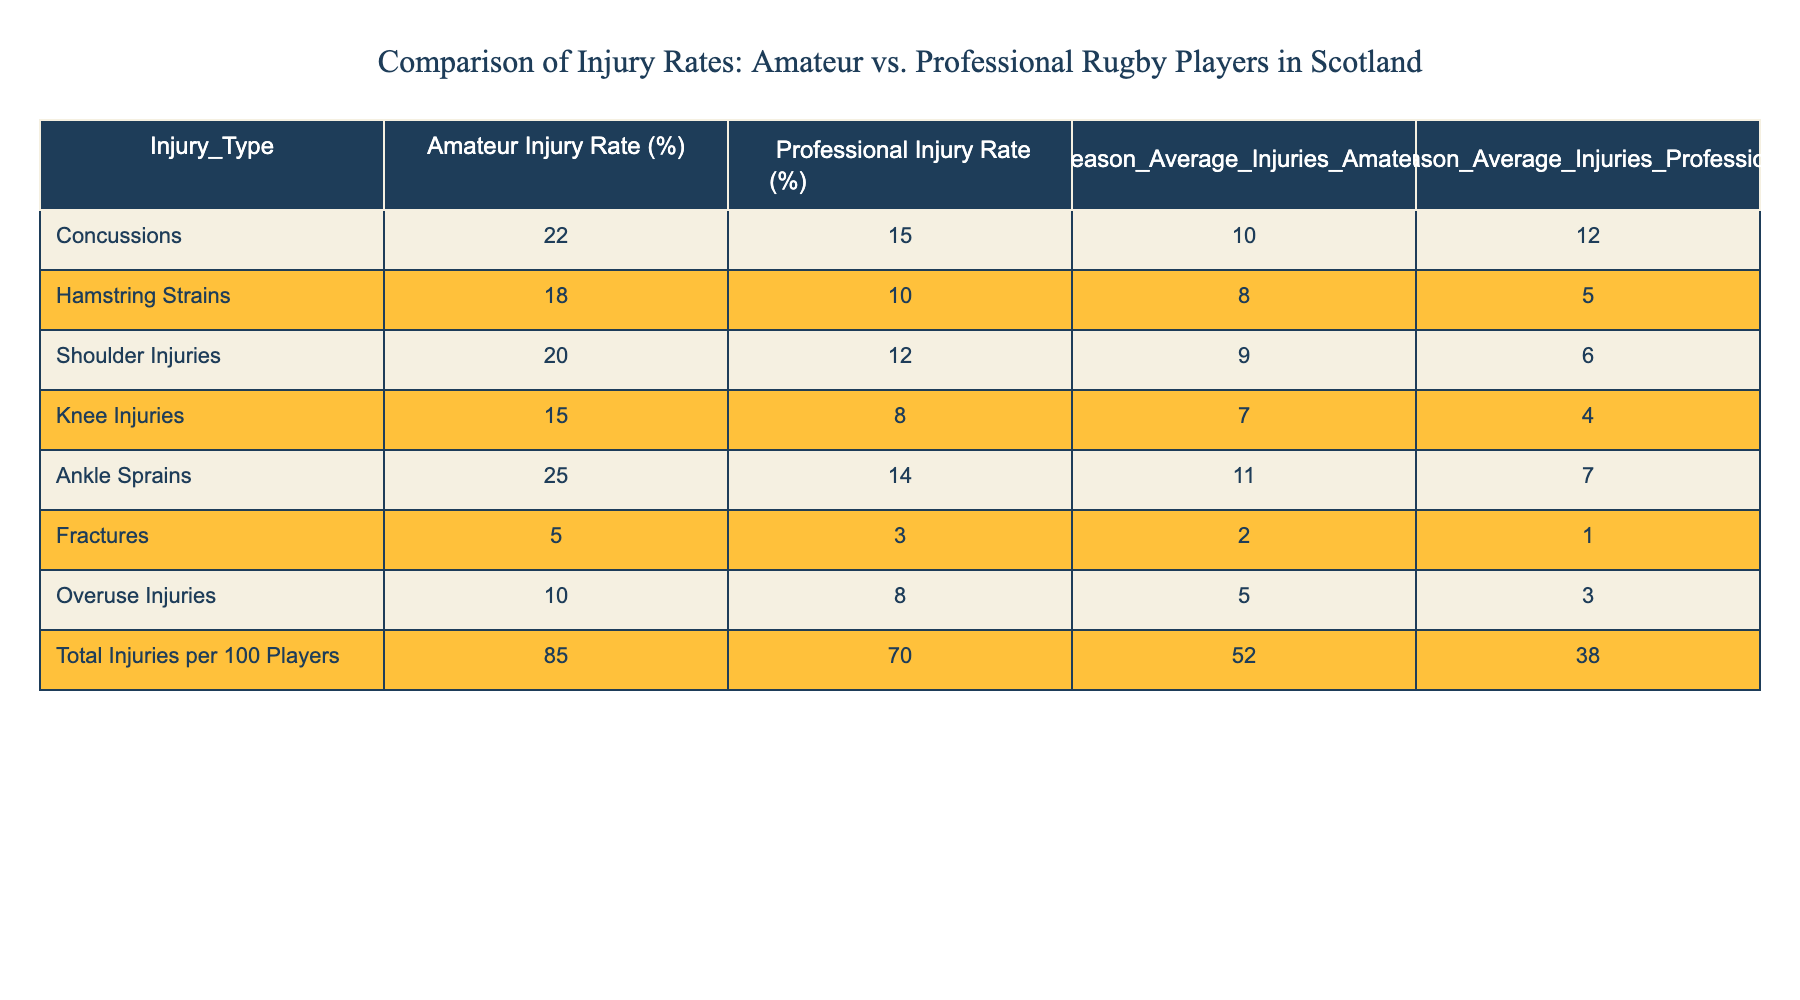What is the injury rate for concussions among amateur rugby players? The data shows that the injury rate for concussions among amateur rugby players is listed as 22%.
Answer: 22% What is the difference in hamstring strain injury rates between amateur and professional rugby players? The amateur injury rate for hamstring strains is 18%, while the professional rate is 10%. The difference is 18% - 10% = 8%.
Answer: 8% Is the total injury rate per 100 players higher for amateurs compared to professionals? The table shows the total injury rate for amateurs is 85, while for professionals, it is 70. Since 85 is greater than 70, the statement is true.
Answer: Yes What is the average number of ankle sprains per season for professional rugby players? The table indicates that the season average injuries for ankle sprains among professional players is 7.
Answer: 7 If we consider all types of injuries, what is the total average number of injuries per season for amateur rugby players? The season average total injuries for amateurs is calculated as 10 (concussions) + 8 (hamstring strains) + 9 (shoulder injuries) + 7 (knee injuries) + 11 (ankle sprains) + 2 (fractures) + 5 (overuse injuries) = 52 total average injuries per season.
Answer: 52 What type of injury has the highest rate among amateur rugby players? Among the listed injuries, the highest percentage is for ankle sprains at 25%.
Answer: Ankle Sprains Is the rate of fractures higher among professional players than amateur players? The rates for fractures are 3% for professionals and 5% for amateurs. Since 5% is higher than 3%, the statement is false.
Answer: No How much more likely are amateur players to sustain shoulder injuries compared to professional players? The amateur injury rate for shoulder injuries is 20%, and for professionals, it is 12%. The difference is 20% - 12% = 8%.
Answer: 8% 